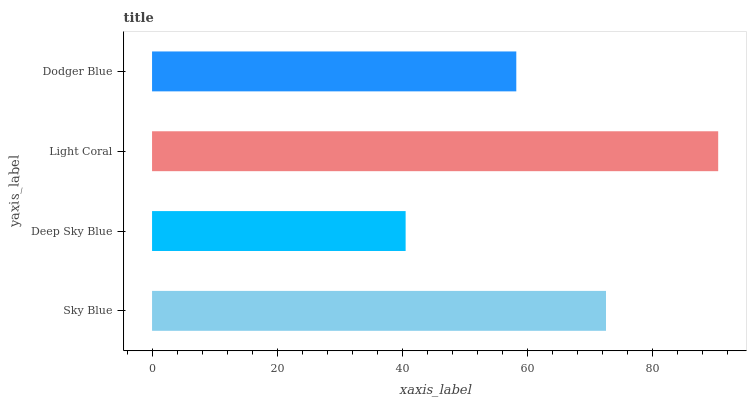Is Deep Sky Blue the minimum?
Answer yes or no. Yes. Is Light Coral the maximum?
Answer yes or no. Yes. Is Light Coral the minimum?
Answer yes or no. No. Is Deep Sky Blue the maximum?
Answer yes or no. No. Is Light Coral greater than Deep Sky Blue?
Answer yes or no. Yes. Is Deep Sky Blue less than Light Coral?
Answer yes or no. Yes. Is Deep Sky Blue greater than Light Coral?
Answer yes or no. No. Is Light Coral less than Deep Sky Blue?
Answer yes or no. No. Is Sky Blue the high median?
Answer yes or no. Yes. Is Dodger Blue the low median?
Answer yes or no. Yes. Is Deep Sky Blue the high median?
Answer yes or no. No. Is Deep Sky Blue the low median?
Answer yes or no. No. 